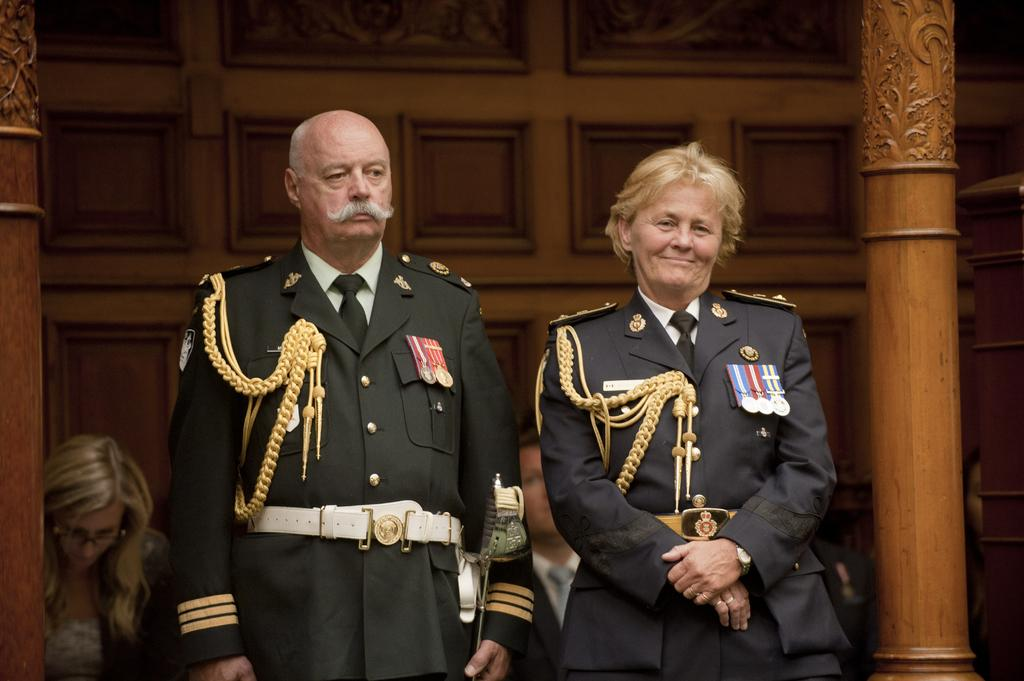How many people are in the image? There are people in the image, but the exact number is not specified. What are the people in the image doing? Some people are standing, while others are sitting. Are there any specific clothing items being worn by some people in the image? Yes, some people are wearing uniforms. Can you describe the facial expression of one of the people in the image? There is a person with a smile on their face. What type of knot is being tied by the person in the image? There is no mention of a knot or any activity involving tying in the image. What is being served for dinner in the image? The image does not depict a dinner or any food being served. 